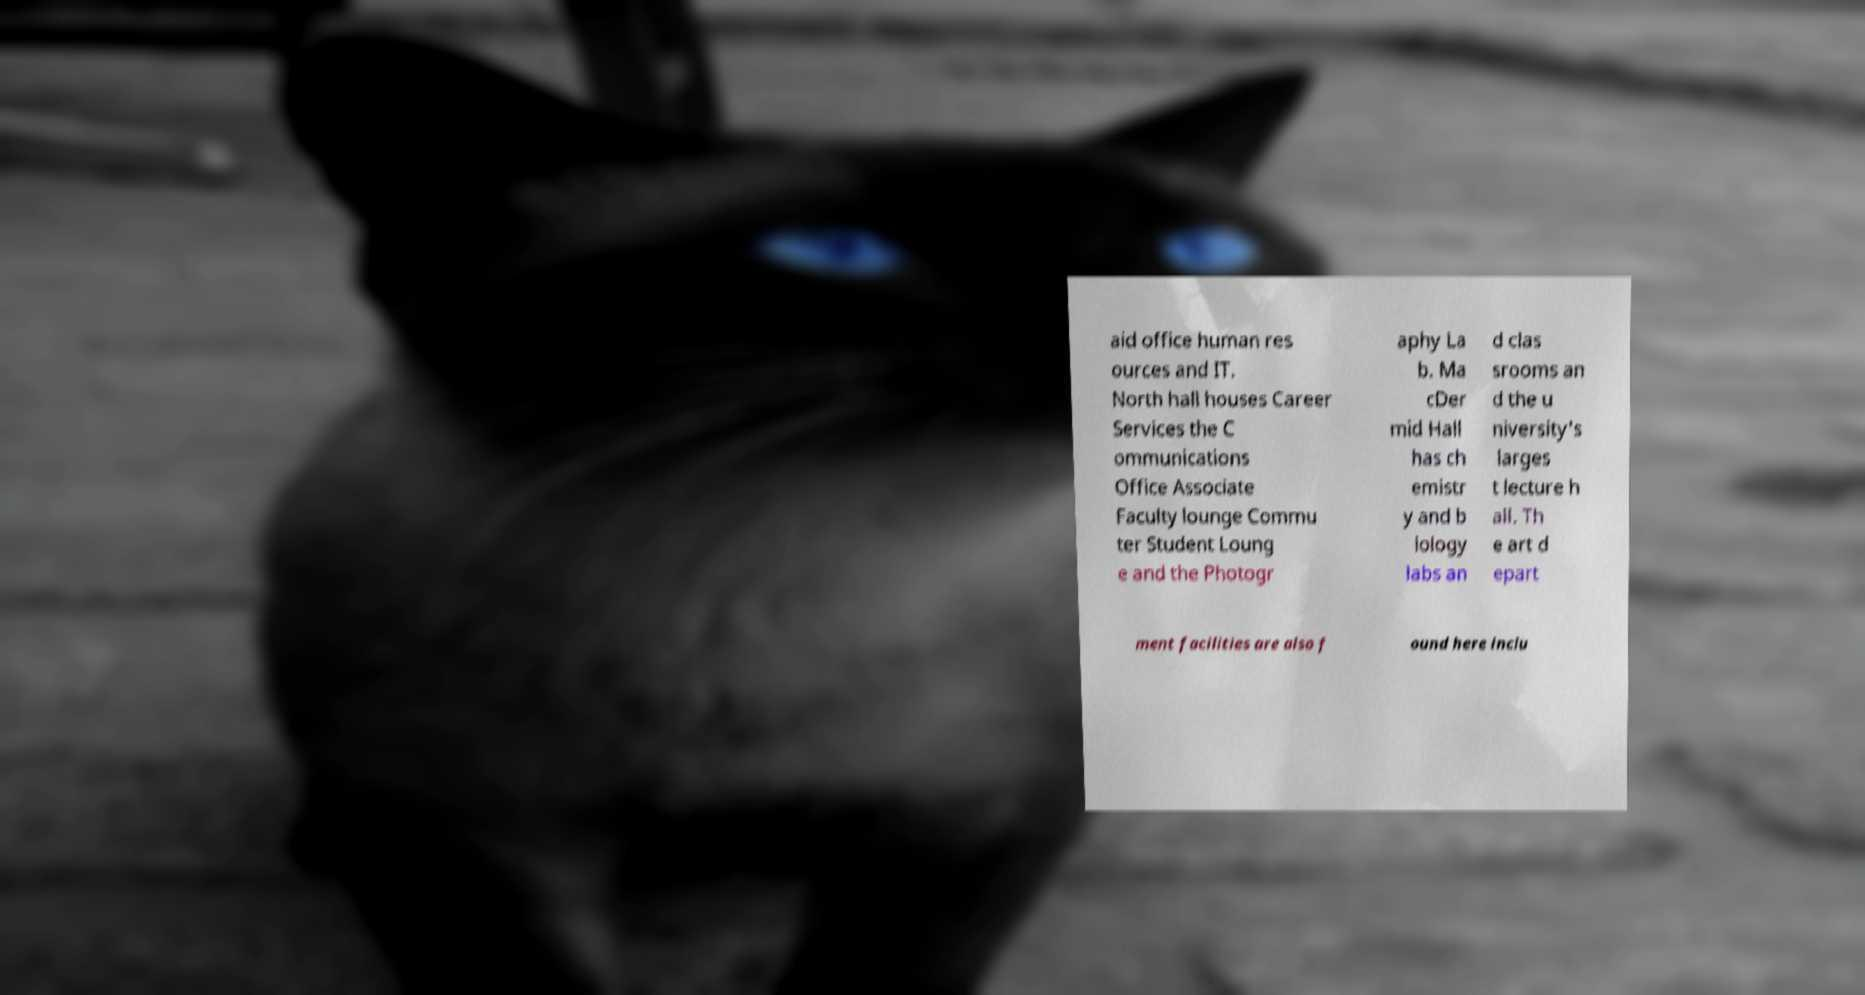There's text embedded in this image that I need extracted. Can you transcribe it verbatim? aid office human res ources and IT. North hall houses Career Services the C ommunications Office Associate Faculty lounge Commu ter Student Loung e and the Photogr aphy La b. Ma cDer mid Hall has ch emistr y and b iology labs an d clas srooms an d the u niversity's larges t lecture h all. Th e art d epart ment facilities are also f ound here inclu 